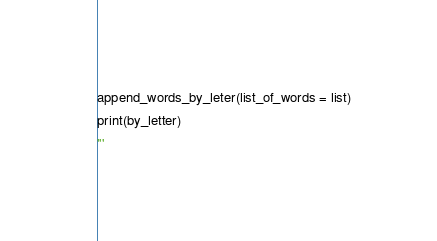Convert code to text. <code><loc_0><loc_0><loc_500><loc_500><_Python_>
append_words_by_leter(list_of_words = list)
print(by_letter)
'''</code> 